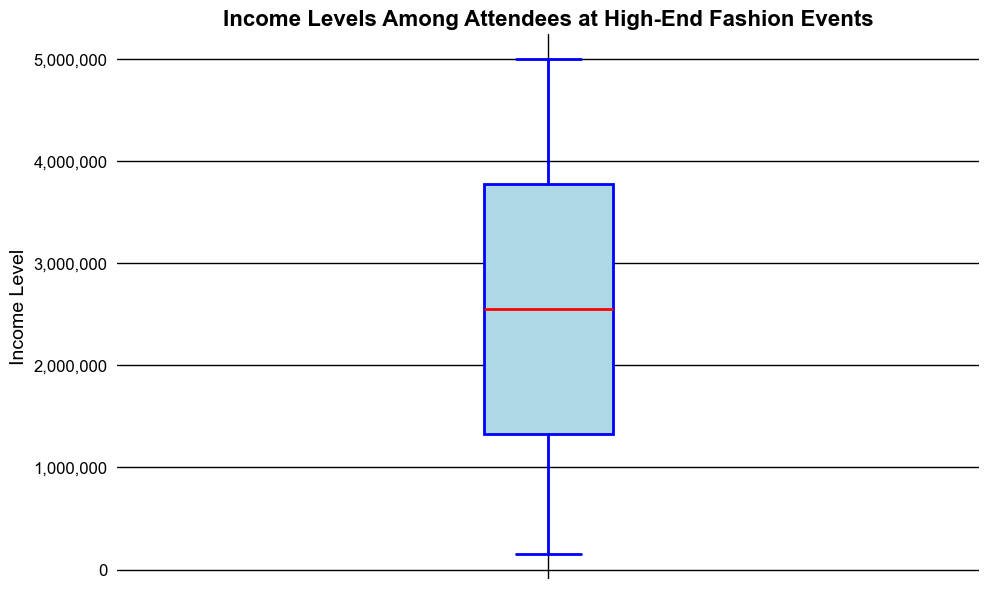What is the median income level among the attendees? The median income level is represented by the red line inside the box plot. This line is located at 2,600,000, which indicates the median value of the income levels among the attendees.
Answer: 2,600,000 What is the range of income levels from the lower to the upper quartile? The lower quartile is the bottom edge of the box and the upper quartile is the top edge of the box. The lower quartile is approximately 1,400,000, and the upper quartile is approximately 3,800,000. The range is the difference between these two values: 3,800,000 - 1,400,000 = 2,400,000.
Answer: 2,400,000 What income level represents the upper whisker? The upper whisker represents the highest value within 1.5 times the interquartile range above the upper quartile. It visually appears to be at 4,800,000.
Answer: 4,800,000 Are there any outliers in the data and what color are they? Outliers are represented by red markers in the box plot. Since there are red points above the whiskers, those are the outliers.
Answer: Yes, red What is the approximate lowest income level recorded among the fashion event attendees? The lowest income level is represented by the bottom whisker of the box plot. The lower whisker appears at approximately 150,000.
Answer: 150,000 How do the income levels in the lower quartile compare to the median income level? The lower quartile income level is around 1,400,000, while the median income level is around 2,600,000. To compare, 2,600,000 - 1,400,000 = 1,200,000 higher.
Answer: 1,200,000 higher What is the income range covered by the box (interquartile range)? The box represents the interquartile range, which spans from the lower quartile (1,400,000) to the upper quartile (3,800,000). Thus, the interquartile range is 3,800,000 - 1,400,000 = 2,400,000.
Answer: 2,400,000 Compare the highest outlier income level to the highest non-outlier income level (upper whisker). The highest outlier income level is around 5,000,000 (since points go up to 5,000,000) and the highest non-outlier income level (upper whisker) is around 4,800,000. Comparing these, 5,000,000 - 4,800,000 = 200,000 higher.
Answer: 200,000 higher What does the width of the box in the box plot indicate? The width of the box does not represent any particular data property; it is purely a visual style decision to display the quartiles and median of the data more clearly.
Answer: No specific meaning 